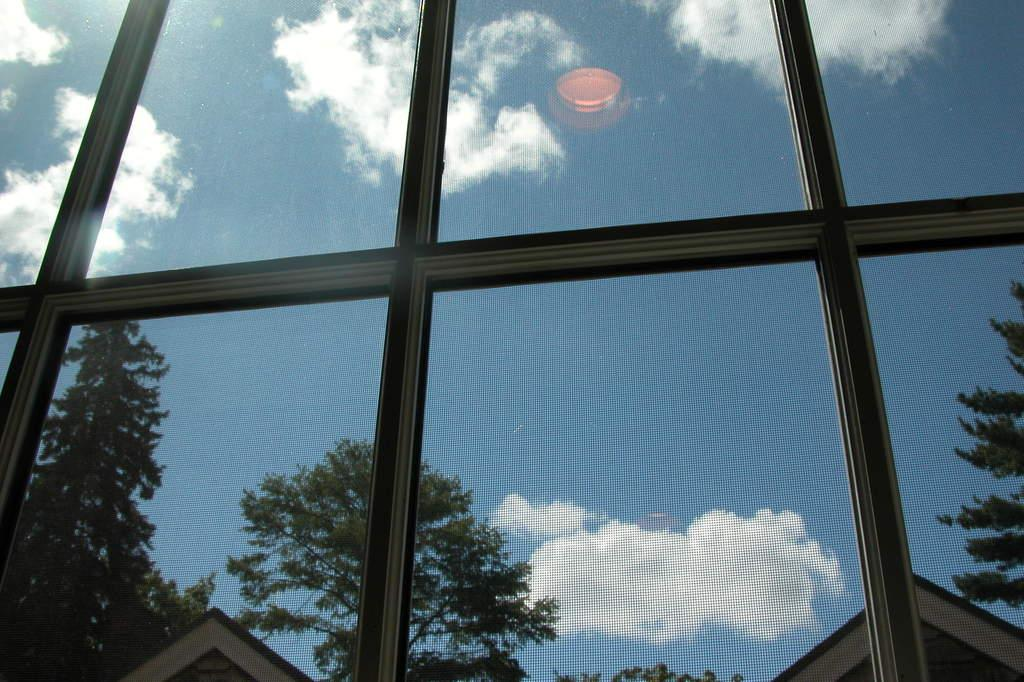What type of material is used for the windows in the image? There are glass windows in the image. What can be seen through the glass windows? Trees and a building are visible through the glass windows. How would you describe the weather based on the image? The sky is cloudy in the image, suggesting a potentially overcast or cloudy day. Can you describe any visual effects present in the image? The reflection of light is present in the image. Where is the nearest park to the location depicted in the image? There is no information about a park or its location in the image. What type of wax is used to create the sculpture visible in the image? There is no sculpture or wax present in the image. 